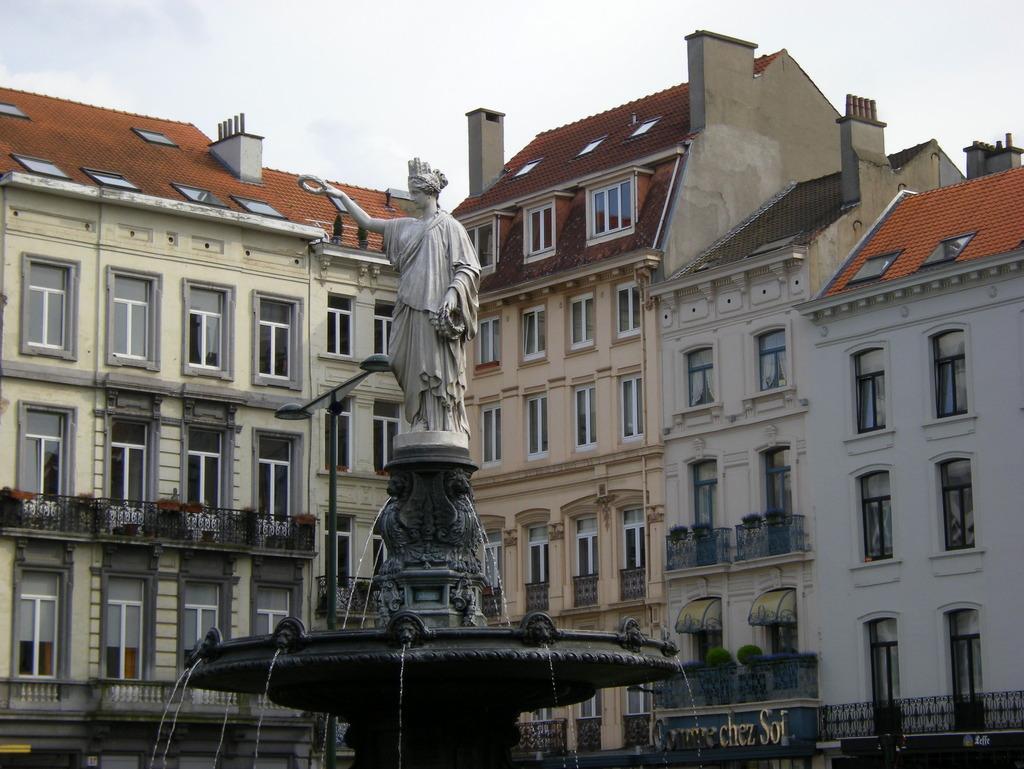In one or two sentences, can you explain what this image depicts? In this picture we can see a statue on a fountain and in the background we can see buildings, electric pole with lights, sky and some objects. 